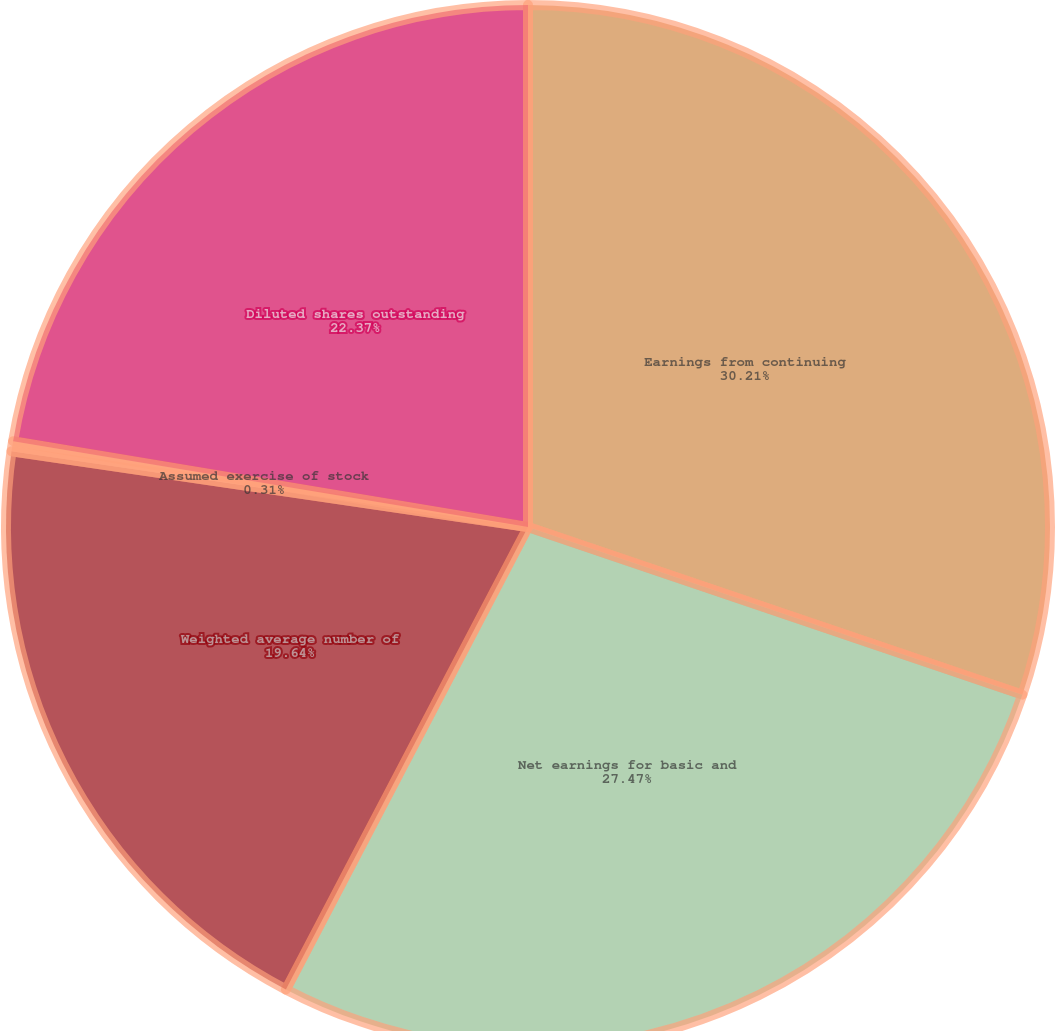Convert chart to OTSL. <chart><loc_0><loc_0><loc_500><loc_500><pie_chart><fcel>Earnings from continuing<fcel>Net earnings for basic and<fcel>Weighted average number of<fcel>Assumed exercise of stock<fcel>Diluted shares outstanding<nl><fcel>30.2%<fcel>27.47%<fcel>19.64%<fcel>0.31%<fcel>22.37%<nl></chart> 